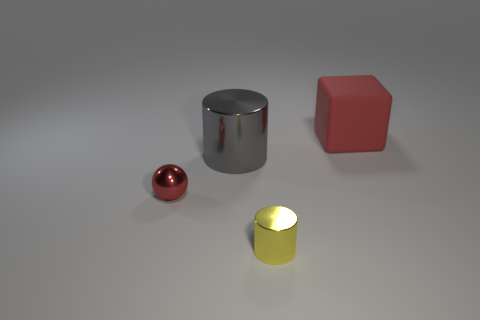Add 4 large brown blocks. How many objects exist? 8 Subtract 0 blue blocks. How many objects are left? 4 Subtract all spheres. How many objects are left? 3 Subtract 2 cylinders. How many cylinders are left? 0 Subtract all cyan cylinders. Subtract all brown blocks. How many cylinders are left? 2 Subtract all red cubes. How many gray cylinders are left? 1 Subtract all purple matte blocks. Subtract all red shiny things. How many objects are left? 3 Add 3 small things. How many small things are left? 5 Add 1 large red objects. How many large red objects exist? 2 Subtract all gray cylinders. How many cylinders are left? 1 